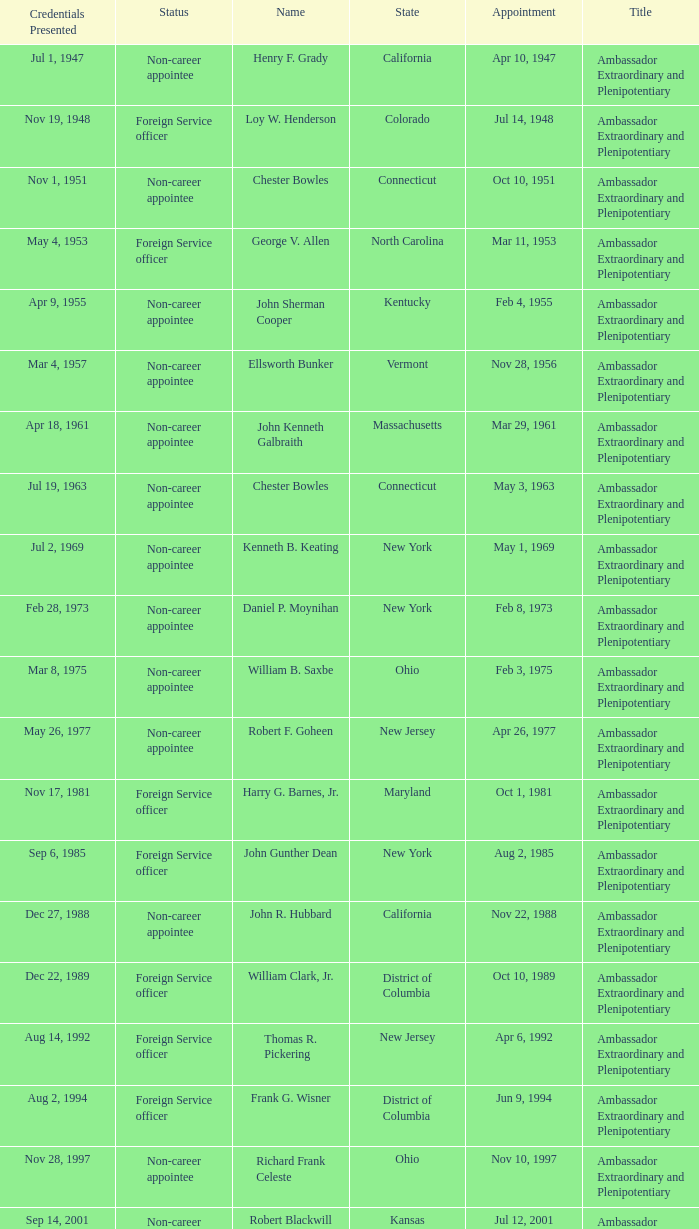What state has an appointment for jul 12, 2001? Kansas. 